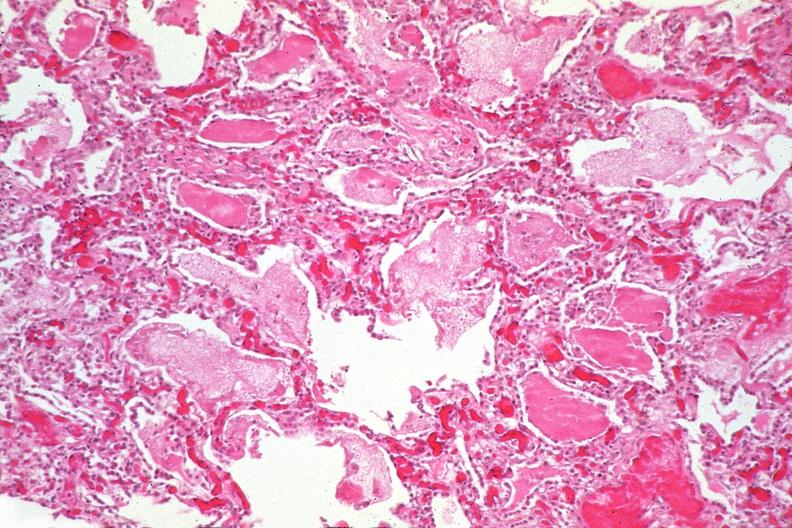what does this image show?
Answer the question using a single word or phrase. Lung 